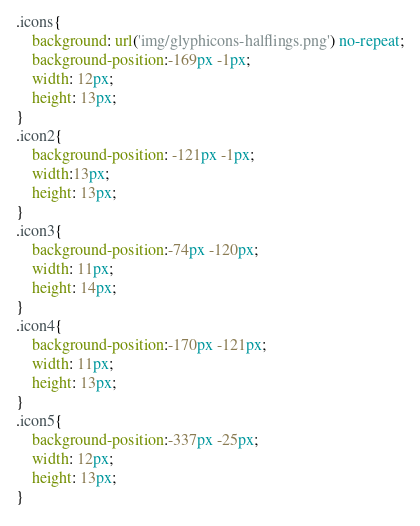Convert code to text. <code><loc_0><loc_0><loc_500><loc_500><_CSS_>.icons{
	background: url('img/glyphicons-halflings.png') no-repeat;
	background-position:-169px -1px;
	width: 12px;
	height: 13px;
}
.icon2{
	background-position: -121px -1px;
	width:13px;
	height: 13px;
}
.icon3{
	background-position:-74px -120px;
	width: 11px;
	height: 14px;
}
.icon4{
	background-position:-170px -121px;
	width: 11px;
	height: 13px;
}
.icon5{
	background-position:-337px -25px;
	width: 12px;
	height: 13px;
}
</code> 